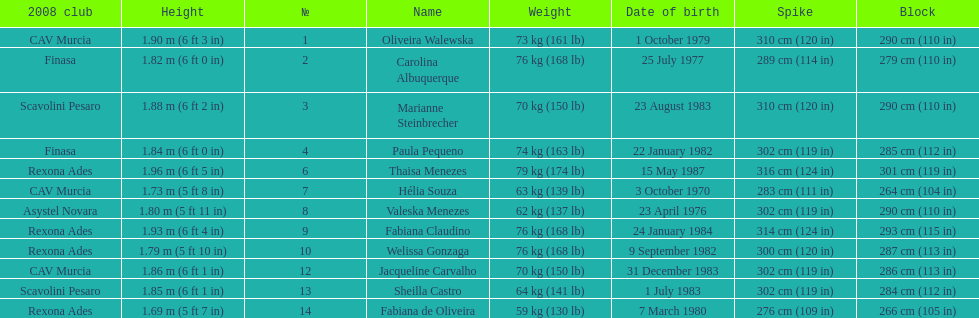Who is the next tallest player after thaisa menezes? Fabiana Claudino. 